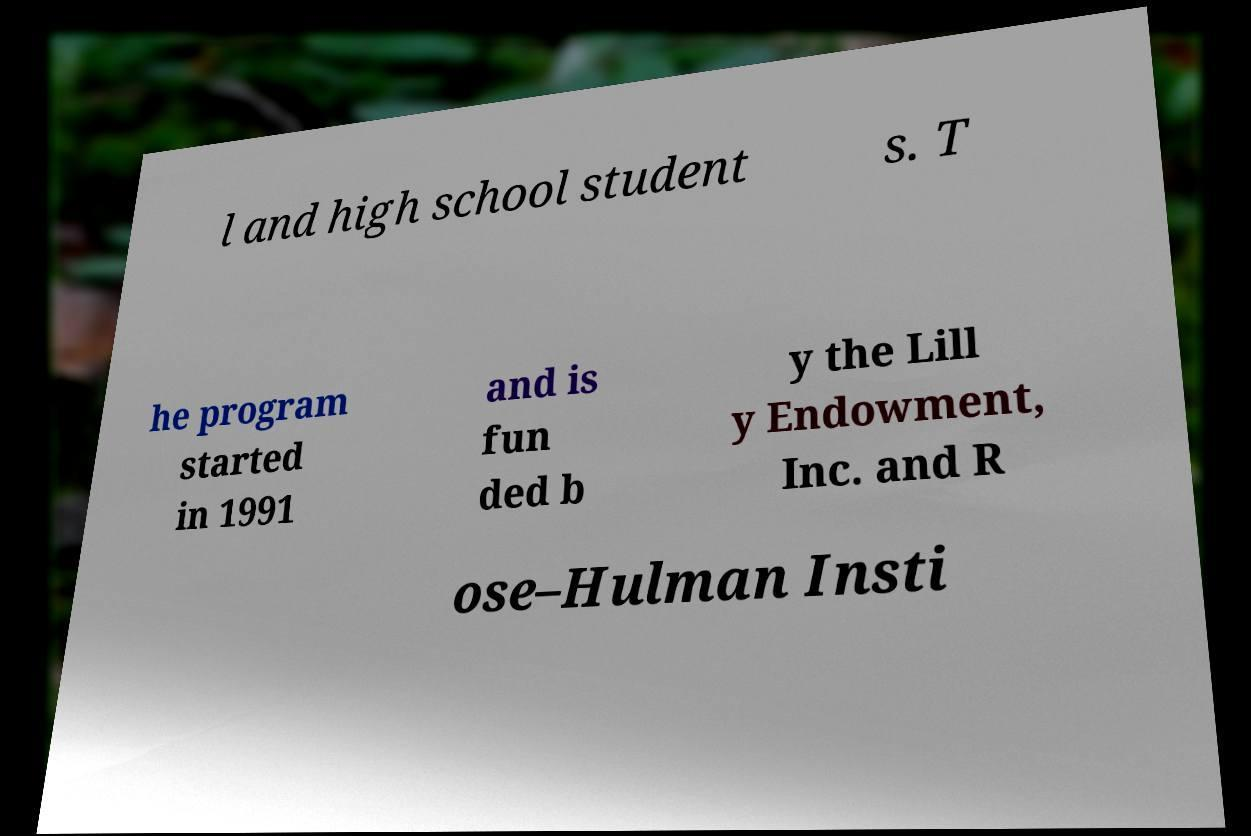Could you extract and type out the text from this image? l and high school student s. T he program started in 1991 and is fun ded b y the Lill y Endowment, Inc. and R ose–Hulman Insti 